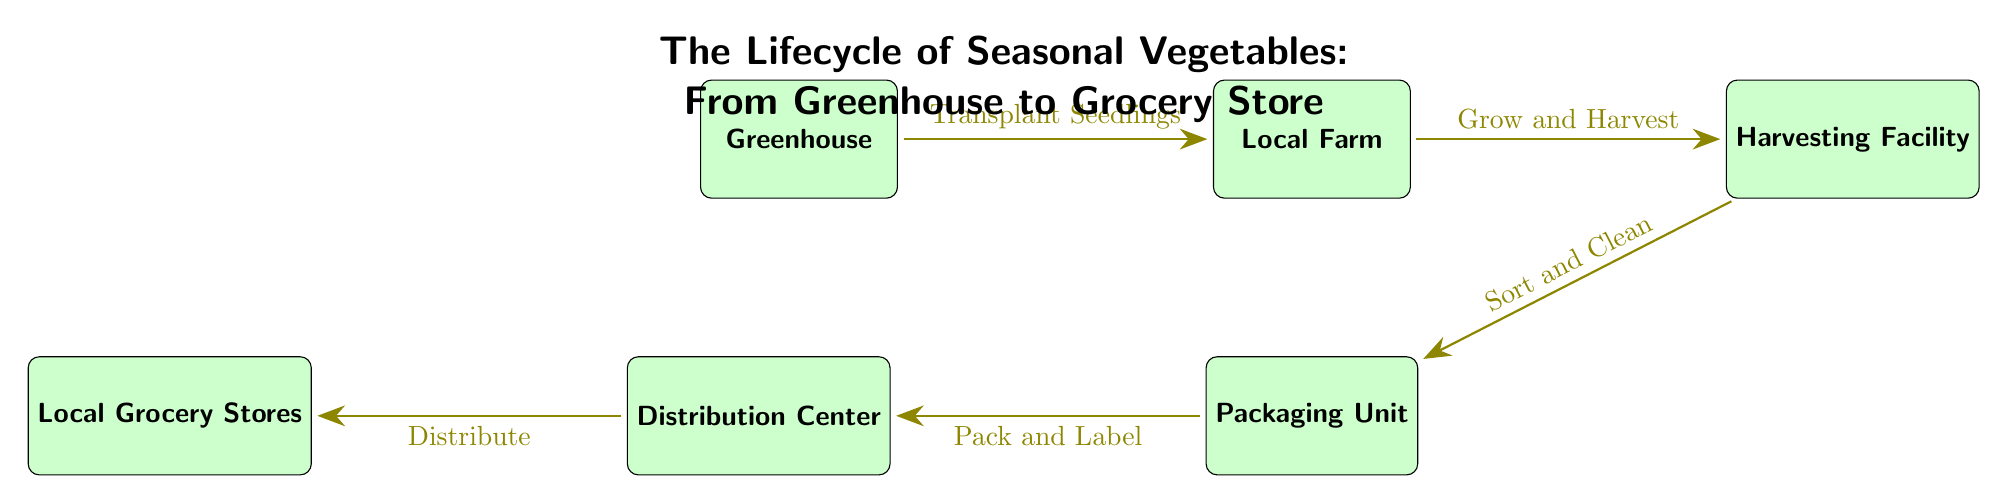What is the first step in the lifecycle? The diagram indicates that the first step is the "Greenhouse," where seedlings are grown.
Answer: Greenhouse How many nodes are represented in the diagram? By counting each distinct box in the diagram, there are a total of 6 nodes.
Answer: 6 What process occurs after "Local Farm"? Following the "Local Farm," the next process is "Harvesting Facility," indicating that harvesting takes place after the vegetables are grown.
Answer: Harvesting Facility What is the last node in the diagram? The diagram shows that the final destination for the vegetables is "Local Grocery Stores," marking the end of the lifecycle.
Answer: Local Grocery Stores Which node is responsible for packaging? The diagram shows that the "Packaging Unit" is where sorting and cleaning are followed by packing and labeling the vegetables.
Answer: Packaging Unit What are vegetables transported for after being labeled? After being packed and labeled in the "Packaging Unit," vegetables are then "Distributed" to their next stop, which is "Distribution Center."
Answer: Distributed What does the arrow from "Distribution Center" point to? The arrow from "Distribution Center" leads directly to "Local Grocery Stores," indicating where the vegetables are sent after distribution.
Answer: Local Grocery Stores How do seedlings transition from the greenhouse? Seedlings transition from the "Greenhouse" to the "Local Farm" through a process labeled "Transplant Seedlings."
Answer: Transplant Seedlings What is the secondary process below "Local Farm"? The secondary process below "Local Farm" relates to the "Packaging Unit," where the vegetables undergo packaging after harvesting.
Answer: Packaging Unit 